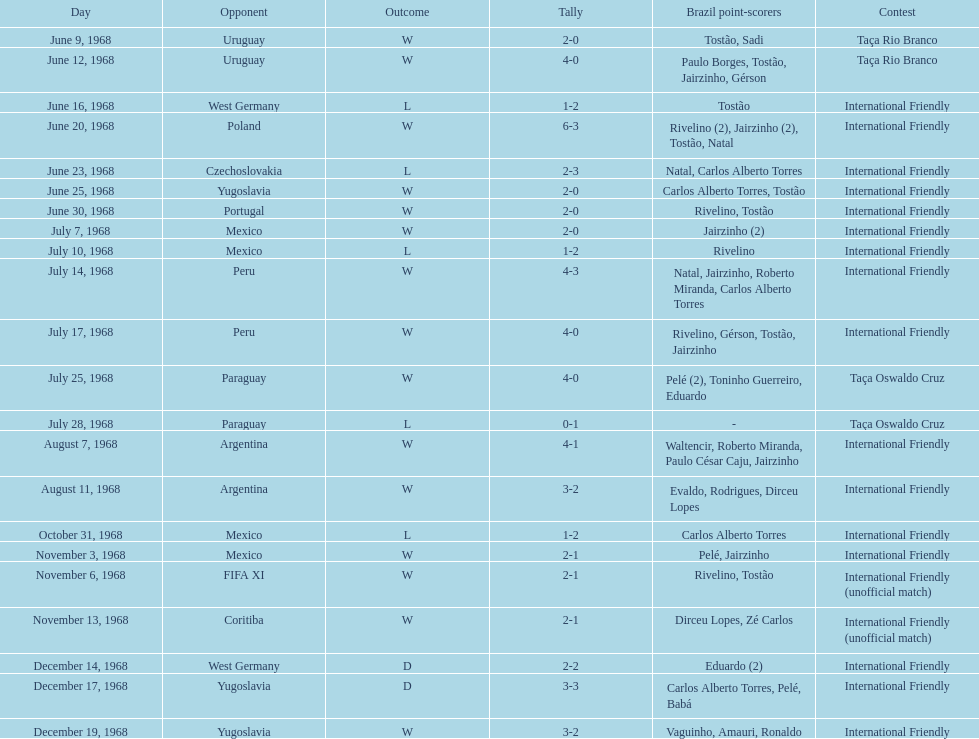What's the total number of ties? 2. 